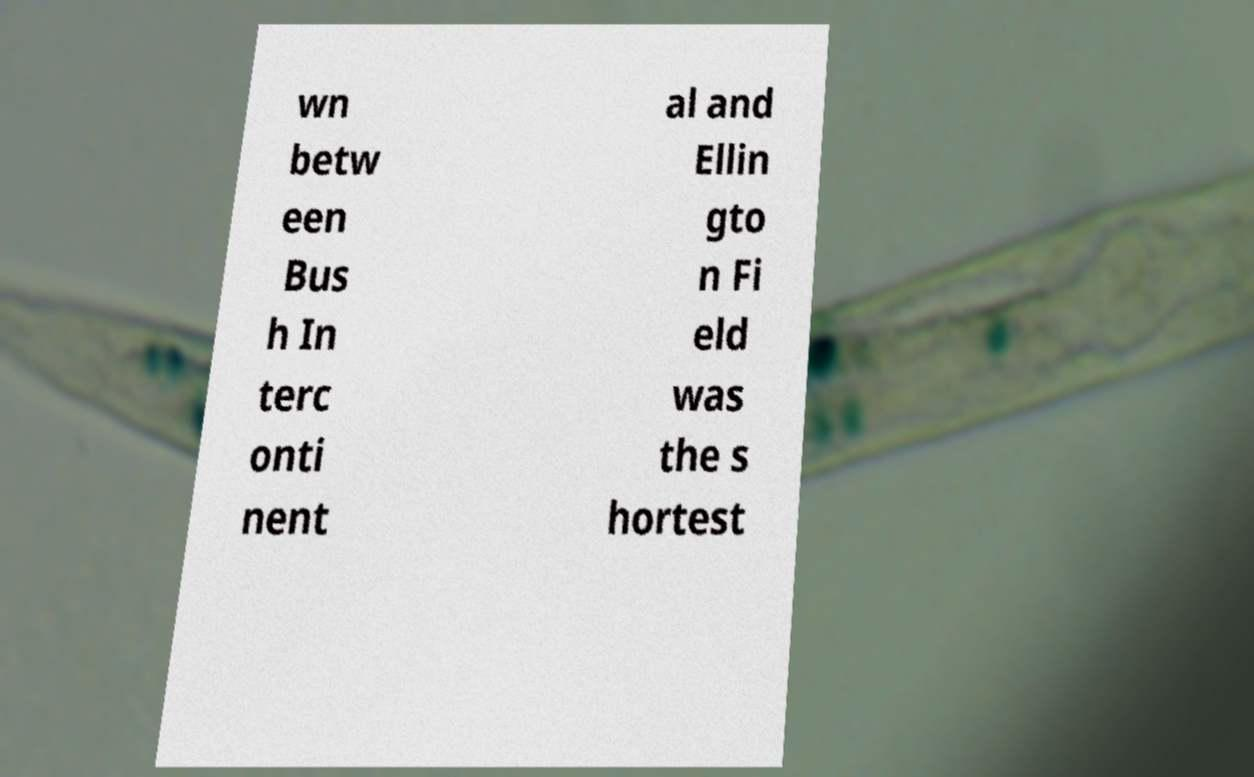Can you accurately transcribe the text from the provided image for me? wn betw een Bus h In terc onti nent al and Ellin gto n Fi eld was the s hortest 